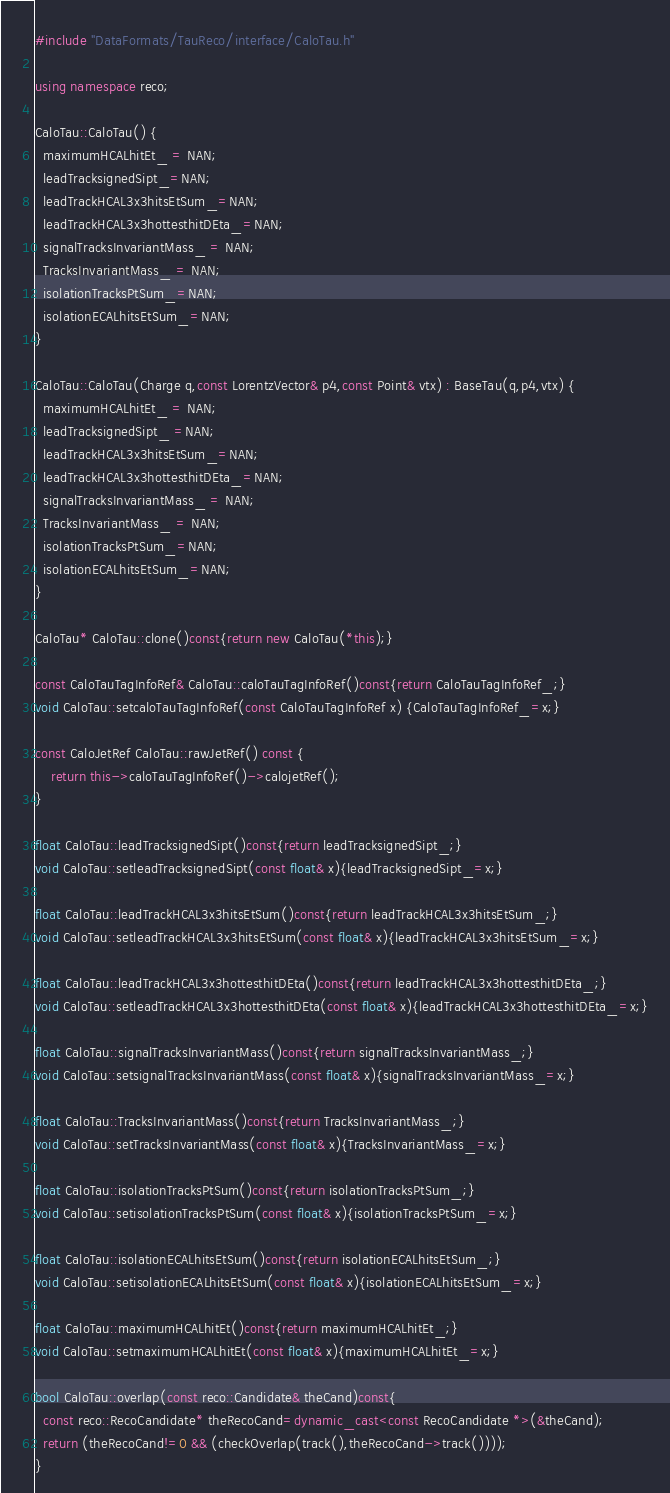Convert code to text. <code><loc_0><loc_0><loc_500><loc_500><_C++_>#include "DataFormats/TauReco/interface/CaloTau.h"

using namespace reco;

CaloTau::CaloTau() {  
  maximumHCALhitEt_ = NAN;
  leadTracksignedSipt_=NAN;
  leadTrackHCAL3x3hitsEtSum_=NAN;
  leadTrackHCAL3x3hottesthitDEta_=NAN;
  signalTracksInvariantMass_ = NAN; 
  TracksInvariantMass_ = NAN;
  isolationTracksPtSum_=NAN;
  isolationECALhitsEtSum_=NAN;
}

CaloTau::CaloTau(Charge q,const LorentzVector& p4,const Point& vtx) : BaseTau(q,p4,vtx) {
  maximumHCALhitEt_ = NAN;
  leadTracksignedSipt_ =NAN;
  leadTrackHCAL3x3hitsEtSum_=NAN;
  leadTrackHCAL3x3hottesthitDEta_=NAN;
  signalTracksInvariantMass_ = NAN; 
  TracksInvariantMass_ = NAN;
  isolationTracksPtSum_=NAN;
  isolationECALhitsEtSum_=NAN;
}

CaloTau* CaloTau::clone()const{return new CaloTau(*this);}

const CaloTauTagInfoRef& CaloTau::caloTauTagInfoRef()const{return CaloTauTagInfoRef_;}
void CaloTau::setcaloTauTagInfoRef(const CaloTauTagInfoRef x) {CaloTauTagInfoRef_=x;}

const CaloJetRef CaloTau::rawJetRef() const {
	return this->caloTauTagInfoRef()->calojetRef();
}

float CaloTau::leadTracksignedSipt()const{return leadTracksignedSipt_;}
void CaloTau::setleadTracksignedSipt(const float& x){leadTracksignedSipt_=x;}

float CaloTau::leadTrackHCAL3x3hitsEtSum()const{return leadTrackHCAL3x3hitsEtSum_;}
void CaloTau::setleadTrackHCAL3x3hitsEtSum(const float& x){leadTrackHCAL3x3hitsEtSum_=x;}

float CaloTau::leadTrackHCAL3x3hottesthitDEta()const{return leadTrackHCAL3x3hottesthitDEta_;}
void CaloTau::setleadTrackHCAL3x3hottesthitDEta(const float& x){leadTrackHCAL3x3hottesthitDEta_=x;}

float CaloTau::signalTracksInvariantMass()const{return signalTracksInvariantMass_;}
void CaloTau::setsignalTracksInvariantMass(const float& x){signalTracksInvariantMass_=x;}

float CaloTau::TracksInvariantMass()const{return TracksInvariantMass_;}
void CaloTau::setTracksInvariantMass(const float& x){TracksInvariantMass_=x;}

float CaloTau::isolationTracksPtSum()const{return isolationTracksPtSum_;}
void CaloTau::setisolationTracksPtSum(const float& x){isolationTracksPtSum_=x;}

float CaloTau::isolationECALhitsEtSum()const{return isolationECALhitsEtSum_;}
void CaloTau::setisolationECALhitsEtSum(const float& x){isolationECALhitsEtSum_=x;}

float CaloTau::maximumHCALhitEt()const{return maximumHCALhitEt_;}
void CaloTau::setmaximumHCALhitEt(const float& x){maximumHCALhitEt_=x;}

bool CaloTau::overlap(const reco::Candidate& theCand)const{
  const reco::RecoCandidate* theRecoCand=dynamic_cast<const RecoCandidate *>(&theCand);
  return (theRecoCand!=0 && (checkOverlap(track(),theRecoCand->track())));
}
</code> 